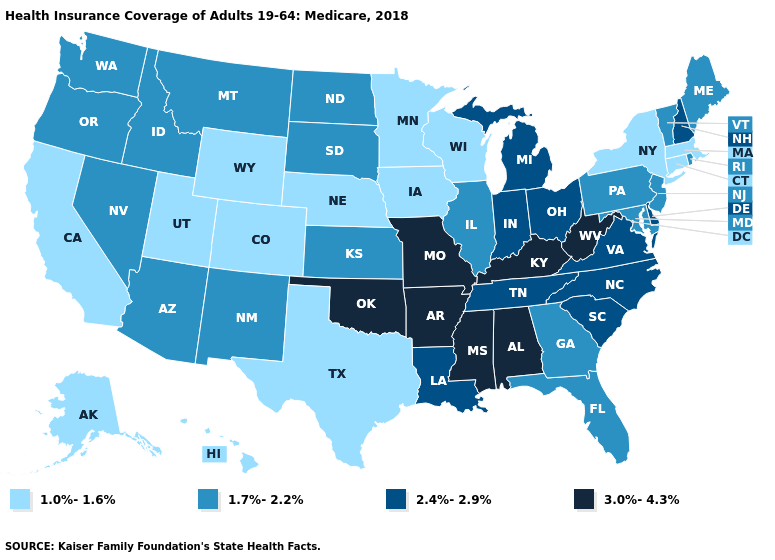Does Connecticut have a lower value than Wyoming?
Short answer required. No. What is the value of Colorado?
Answer briefly. 1.0%-1.6%. Among the states that border Delaware , which have the highest value?
Concise answer only. Maryland, New Jersey, Pennsylvania. Among the states that border New Jersey , which have the lowest value?
Keep it brief. New York. Is the legend a continuous bar?
Be succinct. No. Which states have the lowest value in the USA?
Answer briefly. Alaska, California, Colorado, Connecticut, Hawaii, Iowa, Massachusetts, Minnesota, Nebraska, New York, Texas, Utah, Wisconsin, Wyoming. What is the value of Utah?
Answer briefly. 1.0%-1.6%. Does Missouri have the highest value in the MidWest?
Answer briefly. Yes. Name the states that have a value in the range 1.7%-2.2%?
Concise answer only. Arizona, Florida, Georgia, Idaho, Illinois, Kansas, Maine, Maryland, Montana, Nevada, New Jersey, New Mexico, North Dakota, Oregon, Pennsylvania, Rhode Island, South Dakota, Vermont, Washington. What is the value of New Mexico?
Keep it brief. 1.7%-2.2%. Name the states that have a value in the range 1.7%-2.2%?
Concise answer only. Arizona, Florida, Georgia, Idaho, Illinois, Kansas, Maine, Maryland, Montana, Nevada, New Jersey, New Mexico, North Dakota, Oregon, Pennsylvania, Rhode Island, South Dakota, Vermont, Washington. What is the value of Louisiana?
Give a very brief answer. 2.4%-2.9%. What is the value of New Hampshire?
Write a very short answer. 2.4%-2.9%. How many symbols are there in the legend?
Give a very brief answer. 4. What is the value of Montana?
Write a very short answer. 1.7%-2.2%. 